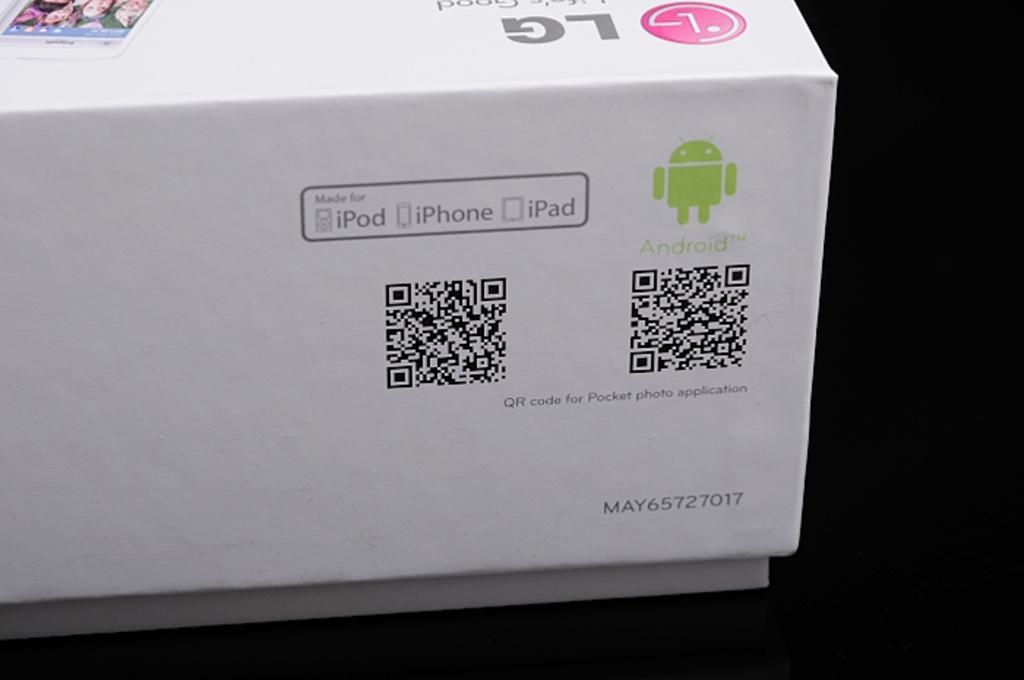Provide a one-sentence caption for the provided image. a box that read ipod iphone and ipad  as well as android. 